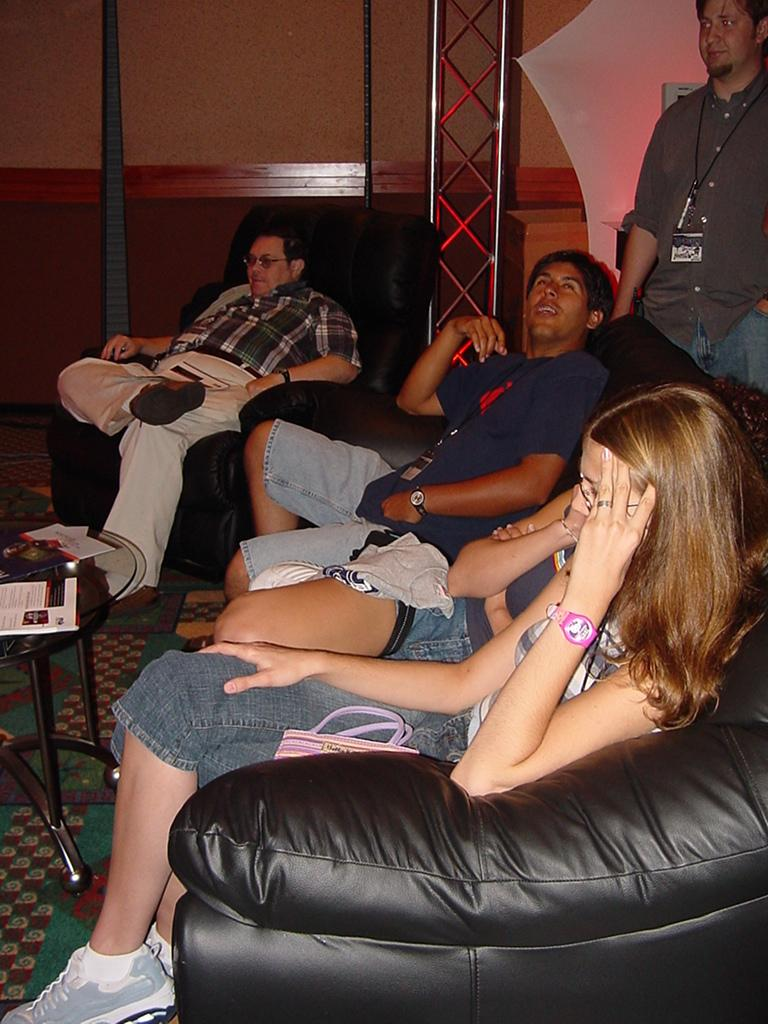What are the people in the image doing? The people in the image are sitting on sofas. Where are the people sitting in relation to the table? The people are sitting in front of the table. What is on the table in the image? There is a paper on the table. Can you describe the person behind the table? There is a person visible behind the table. What is the stranger learning about the size of the table in the image? There is no stranger present in the image, and therefore no learning about the size of the table can be observed. 